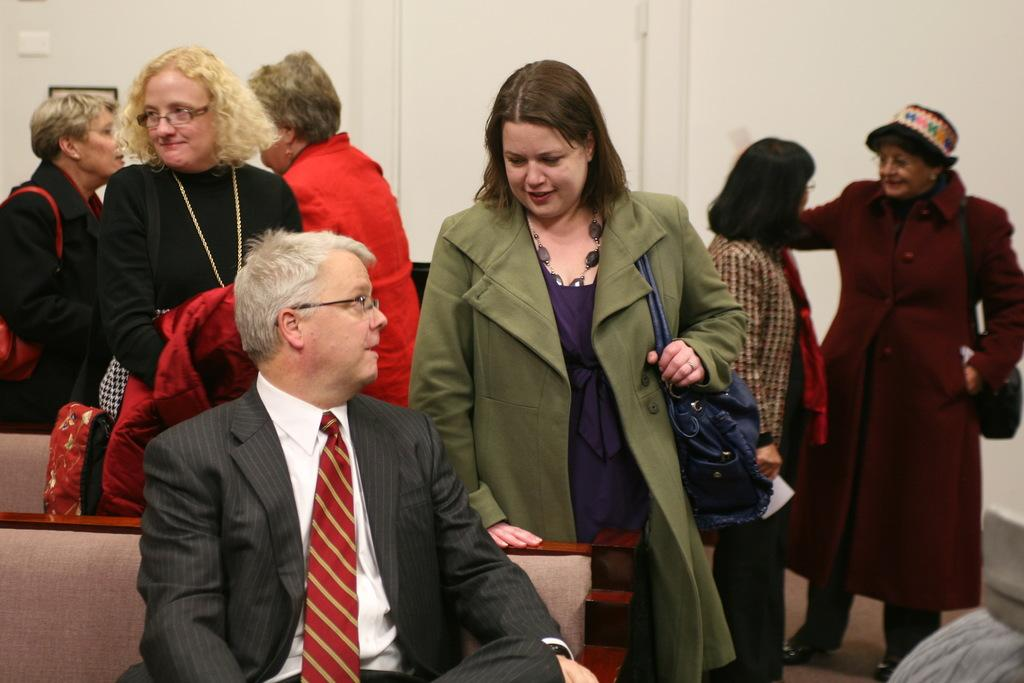What are the people in the image doing? The people in the image are standing and wearing bags. Can you describe the position of one person in the image? One person is sitting on a bench. What can be seen in the background of the image? There is a wall in the background of the image. What is visible at the bottom of the image? There is a floor visible at the bottom of the image. What color is the balloon that the person is pulling in the image? There is no balloon present in the image, and no one is pulling anything. 